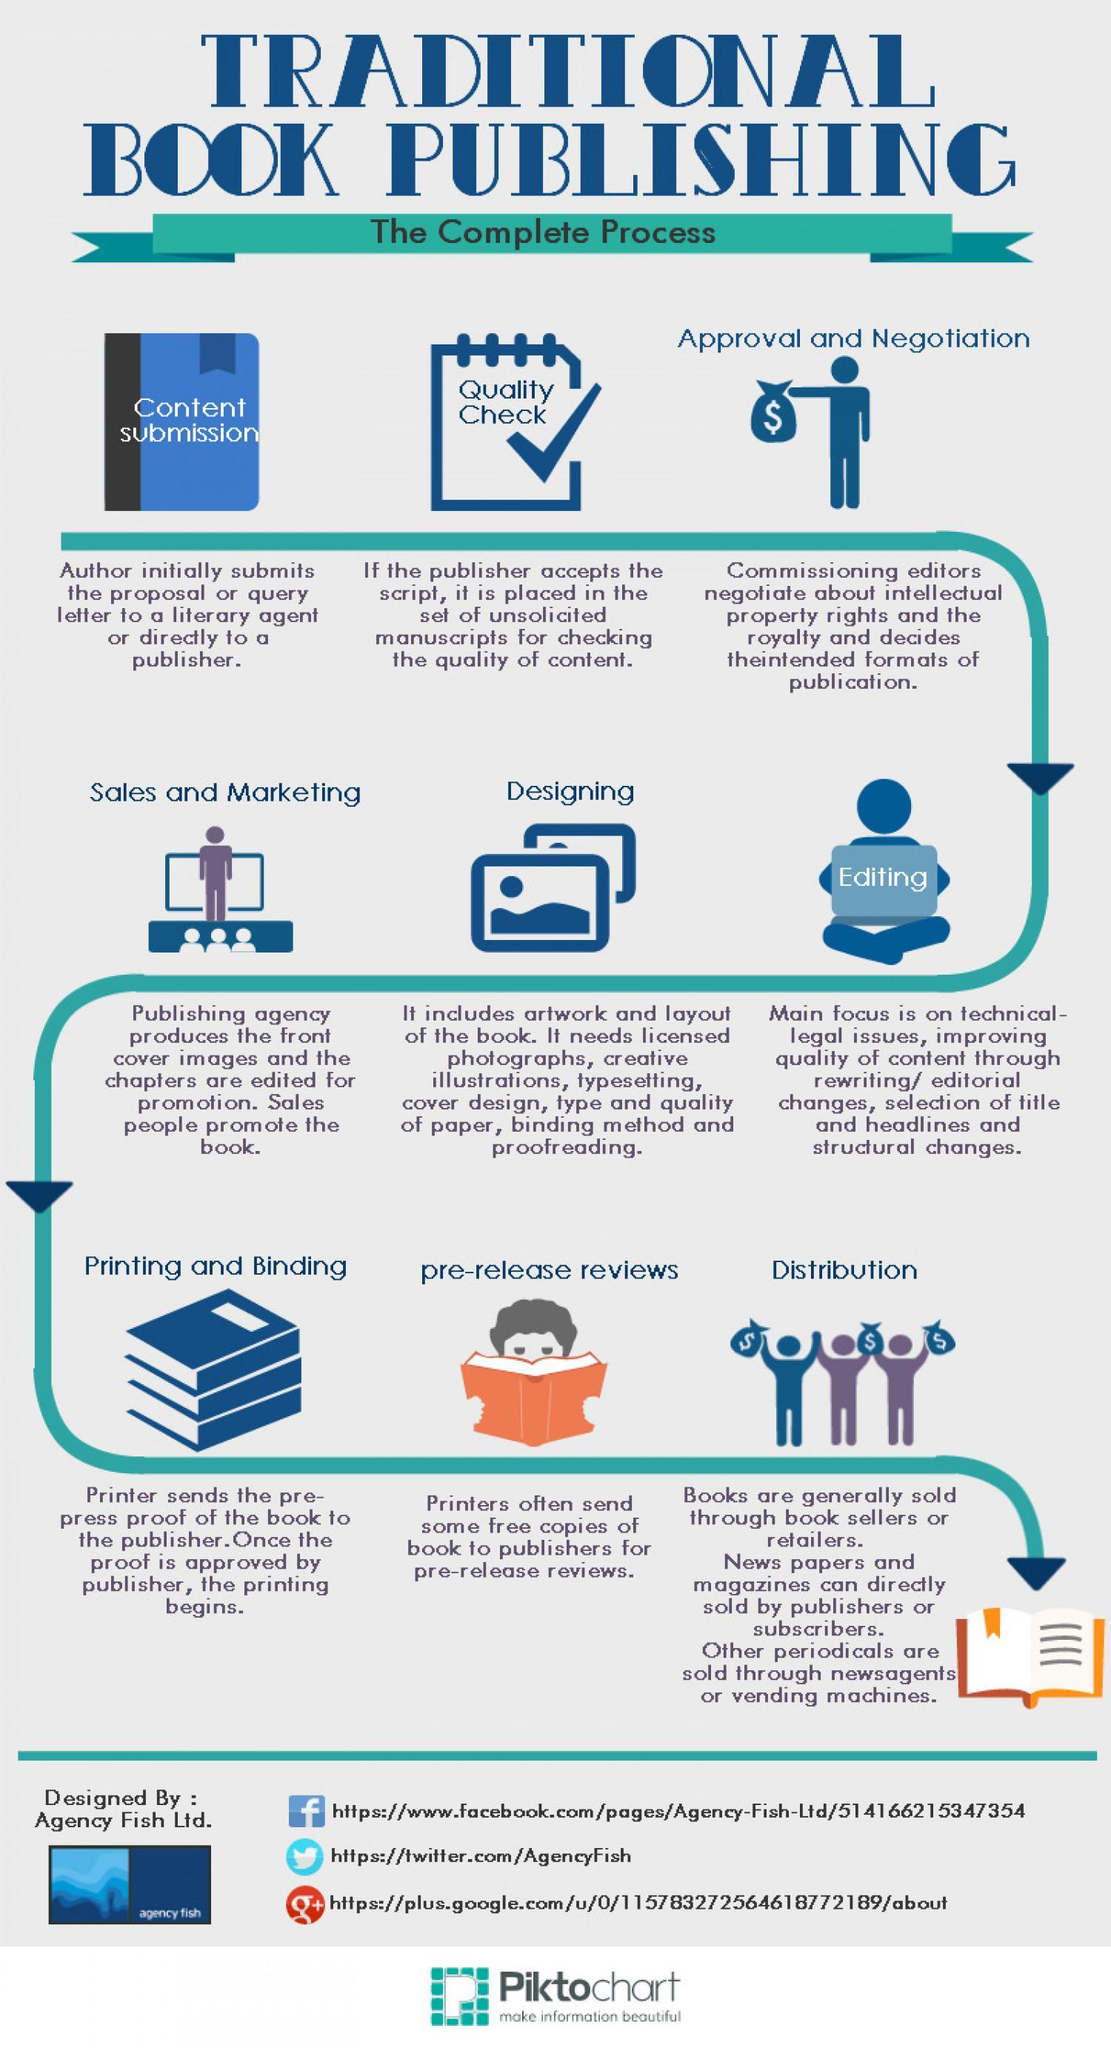What is the Twitter handle name given?
Answer the question with a short phrase. AgencyFish How many books are shown under printing and binding? 3 What is the colour of the book held by the boy under pre-release reviews- orange, red or blue? orange 